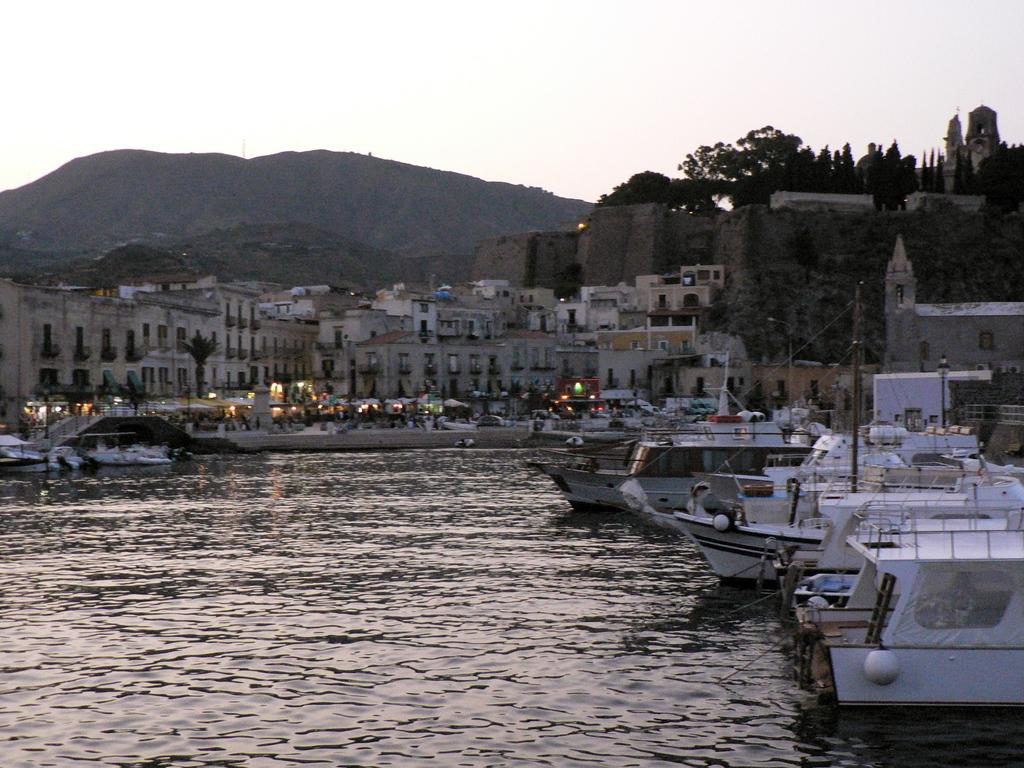What type of vehicles can be seen in the water in the image? There are ships in the water in the image. What structures can be seen in the image? There are buildings visible in the image. What type of natural elements are present in the image? Trees are present in the image. What geographical features can be seen in the image? There are hills in the image. Where is the playground located in the image? There is no playground present in the image. What type of grape is growing on the trees in the image? There are no grapes present in the image, as the trees are not mentioned to be fruit-bearing trees. 